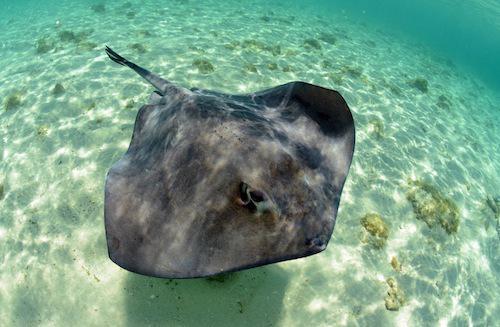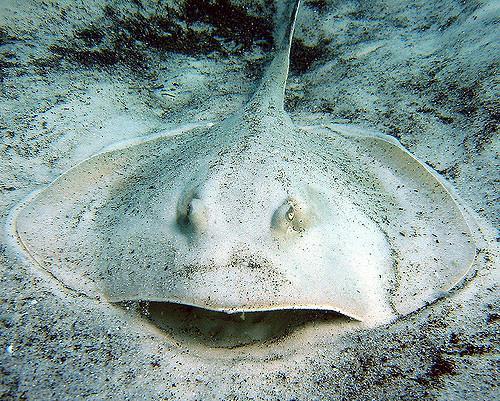The first image is the image on the left, the second image is the image on the right. Considering the images on both sides, is "Right image shows one pale, almost white stingray." valid? Answer yes or no. Yes. The first image is the image on the left, the second image is the image on the right. For the images displayed, is the sentence "A single spotted ray is swimming directly away from the camera." factually correct? Answer yes or no. No. 